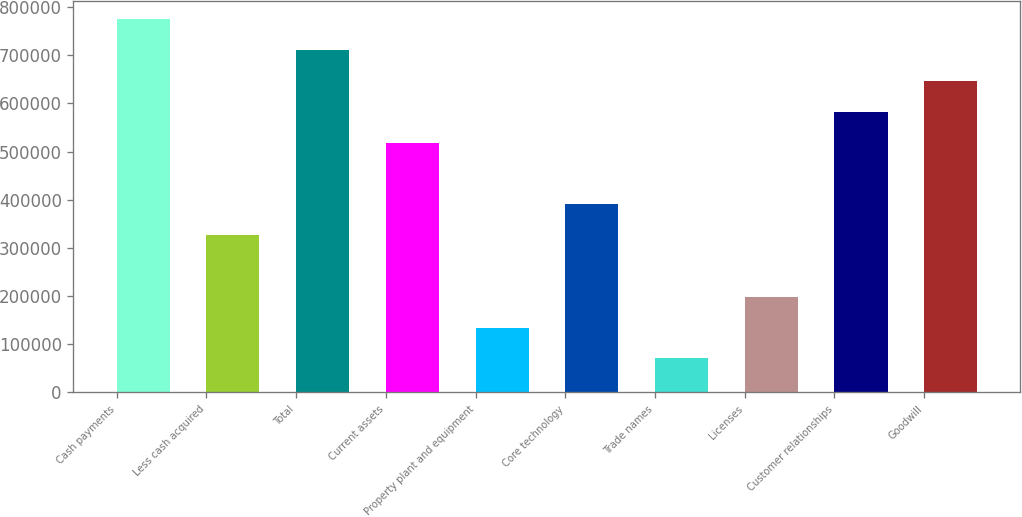Convert chart. <chart><loc_0><loc_0><loc_500><loc_500><bar_chart><fcel>Cash payments<fcel>Less cash acquired<fcel>Total<fcel>Current assets<fcel>Property plant and equipment<fcel>Core technology<fcel>Trade names<fcel>Licenses<fcel>Customer relationships<fcel>Goodwill<nl><fcel>774270<fcel>326436<fcel>710293<fcel>518364<fcel>134507<fcel>390412<fcel>70530.3<fcel>198483<fcel>582341<fcel>646317<nl></chart> 